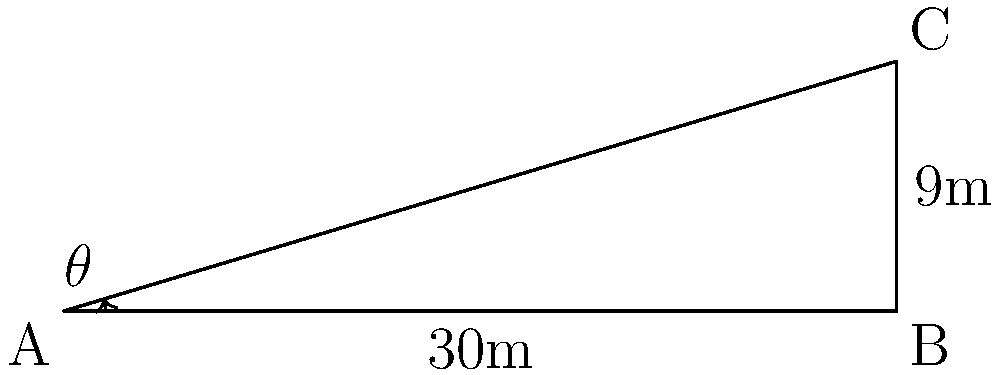As part of implementing stricter regulations on coal mining operations, you need to determine the maximum safe angle of inclination for a mine slope. A proposed mine slope has a horizontal distance of 30 meters and a vertical rise of 9 meters. Calculate the angle of inclination ($\theta$) for this slope to the nearest degree. Is this angle within the safe range if the maximum allowable angle for stable slopes in the area is 20°? To solve this problem, we'll use the tangent trigonometric ratio. Here's a step-by-step approach:

1) In a right-angled triangle, tangent of an angle is the ratio of the opposite side to the adjacent side.

2) In this case:
   - The vertical rise (opposite side) is 9 meters
   - The horizontal distance (adjacent side) is 30 meters

3) We can express this as:

   $$\tan(\theta) = \frac{\text{opposite}}{\text{adjacent}} = \frac{9}{30} = 0.3$$

4) To find $\theta$, we need to use the inverse tangent (arctangent) function:

   $$\theta = \tan^{-1}(0.3)$$

5) Using a calculator or trigonometric tables:

   $$\theta \approx 16.70^\circ$$

6) Rounding to the nearest degree:

   $$\theta \approx 17^\circ$$

7) Comparing with the maximum allowable angle:
   17° < 20°

Therefore, the angle of inclination is within the safe range for stable slopes in the area.
Answer: 17°; Yes, it's within the safe range. 